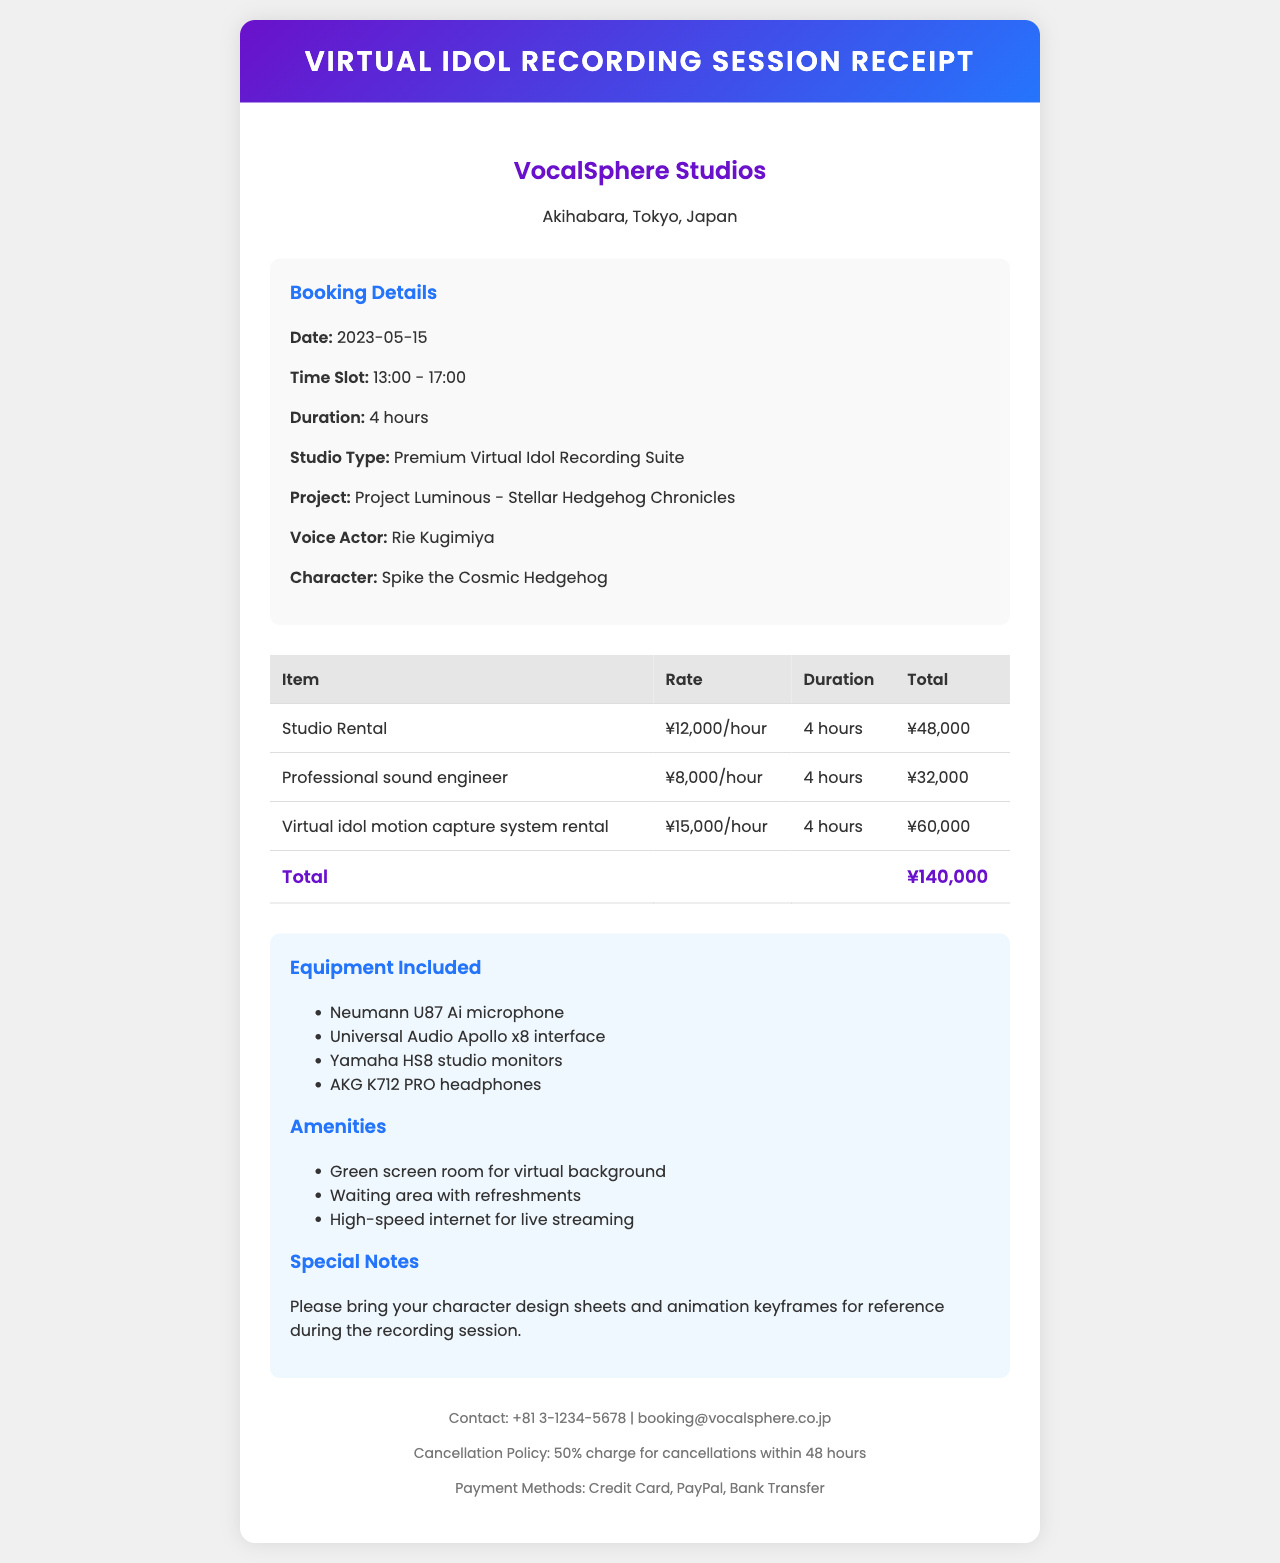what is the studio name? The studio name is listed at the top of the document.
Answer: VocalSphere Studios what is the location of the studio? The location of the studio is mentioned in the document under studio info.
Answer: Akihabara, Tokyo, Japan what is the date of the recording session? The date is specified in the booking details section of the document.
Answer: 2023-05-15 how long is the booking duration? The booking duration is listed in the booking details section.
Answer: 4 hours who is the voice actor? The voice actor's name is mentioned in the booking details section.
Answer: Rie Kugimiya what is included in the studio rental? The items included in the studio are listed under equipment included.
Answer: Neumann U87 Ai microphone, Universal Audio Apollo x8 interface, Yamaha HS8 studio monitors, AKG K712 PRO headphones what is the total cost of the session? The total cost is calculated from the studio rental and additional services.
Answer: ¥ 108,000 what is the cancellation policy? The cancellation policy is specified at the end of the document.
Answer: 50% charge for cancellations within 48 hours what payment methods are available? The available payment methods are listed in the footer of the document.
Answer: Credit Card, PayPal, Bank Transfer what special notes are provided for the session? Special notes are included in the additional information section of the document.
Answer: Please bring your character design sheets and animation keyframes for reference during the recording session 